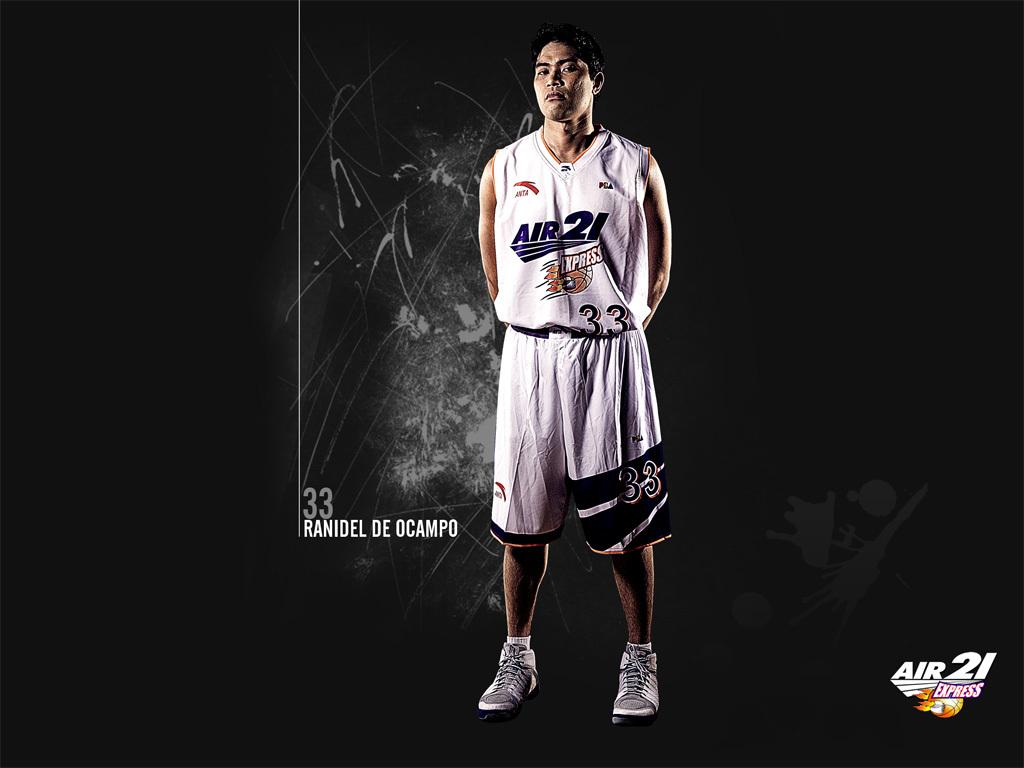What team does he play for?
Keep it short and to the point. Air 21 express. 